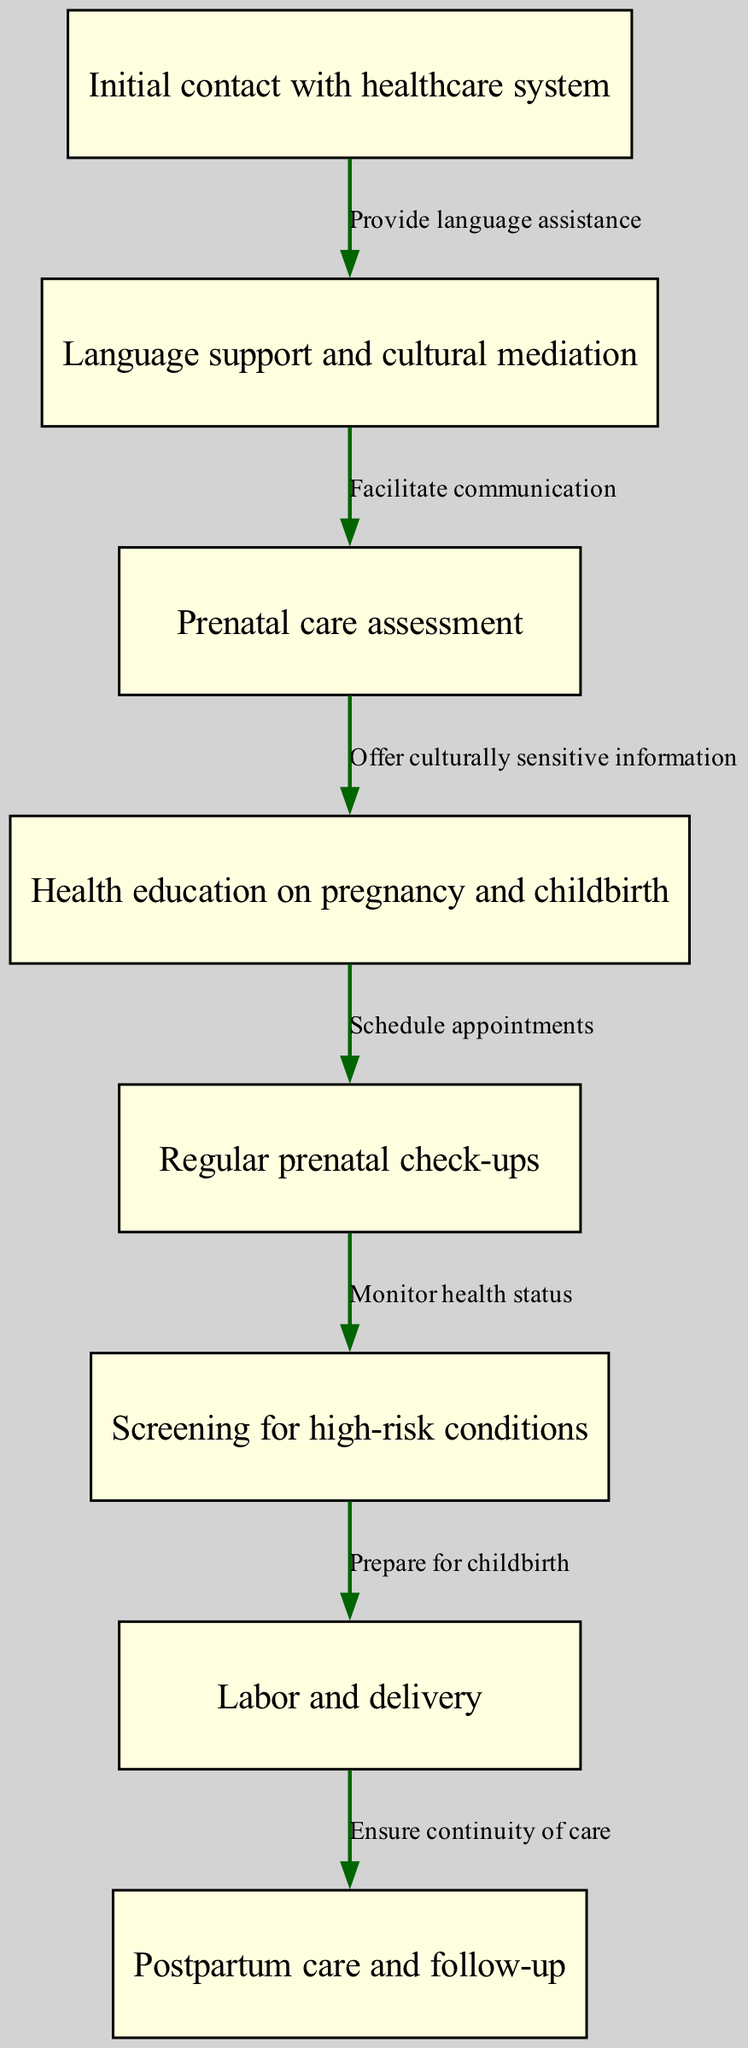What is the first node in the pathway? The first node in the pathway is identified as "Initial contact with healthcare system." This is the starting point for the maternal health care pathway.
Answer: Initial contact with healthcare system How many total nodes are there in the diagram? Counting each unique step represented, there are eight different nodes listed in the diagram, which represent various stages in the maternal health care pathway.
Answer: 8 What is the second step after "Initial contact with healthcare system"? After "Initial contact with healthcare system," the second step is "Language support and cultural mediation." This is indicated by the edge connecting node one to node two.
Answer: Language support and cultural mediation What does "Screening for high-risk conditions" lead to? "Screening for high-risk conditions" leads directly to "Labor and delivery." This relationship shows the pathway's progression after assessing potential risks during pregnancy.
Answer: Labor and delivery What type of support is provided after "Language support and cultural mediation"? Following "Language support and cultural mediation," the type of support provided is "Prenatal care assessment." This is a critical assessment that comes after ensuring effective communication.
Answer: Prenatal care assessment What is the relationship between "Labor and delivery" and "Postpartum care and follow-up"? The relationship between "Labor and delivery" and "Postpartum care and follow-up" is characterized by a direct edge indicating "Ensure continuity of care." This highlights the importance of continued care after childbirth.
Answer: Ensure continuity of care What step occurs immediately before "Regular prenatal check-ups"? The step that occurs immediately before "Regular prenatal check-ups" is "Health education on pregnancy and childbirth." This step prepares and informs the patient before they continue with regular check-ups.
Answer: Health education on pregnancy and childbirth How is "Screening for high-risk conditions" connected to the overall pathway? "Screening for high-risk conditions" is connected to "Labor and delivery," meaning it plays a critical role in determining how the pregnancy will progress toward childbirth based on assessed risks.
Answer: Labor and delivery 